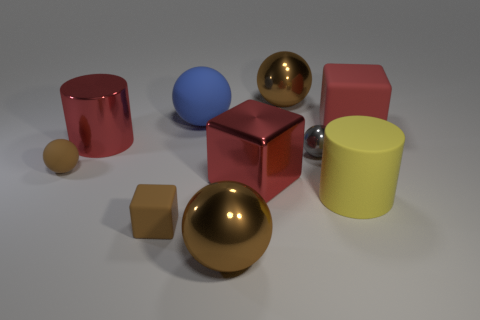Subtract all red blocks. How many brown spheres are left? 3 Subtract all blue balls. How many balls are left? 4 Subtract all blue balls. How many balls are left? 4 Subtract 1 blocks. How many blocks are left? 2 Subtract all gray balls. Subtract all green cylinders. How many balls are left? 4 Subtract all cubes. How many objects are left? 7 Add 6 purple spheres. How many purple spheres exist? 6 Subtract 2 brown spheres. How many objects are left? 8 Subtract all big yellow matte cylinders. Subtract all blue matte objects. How many objects are left? 8 Add 5 small gray balls. How many small gray balls are left? 6 